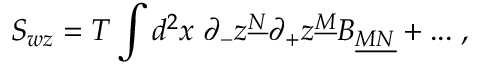<formula> <loc_0><loc_0><loc_500><loc_500>S _ { w z } = T \int d ^ { 2 } x \, \partial _ { - } z ^ { \underline { N } } \partial _ { + } z ^ { \underline { M } } B _ { \underline { M N } } + \dots \, ,</formula> 